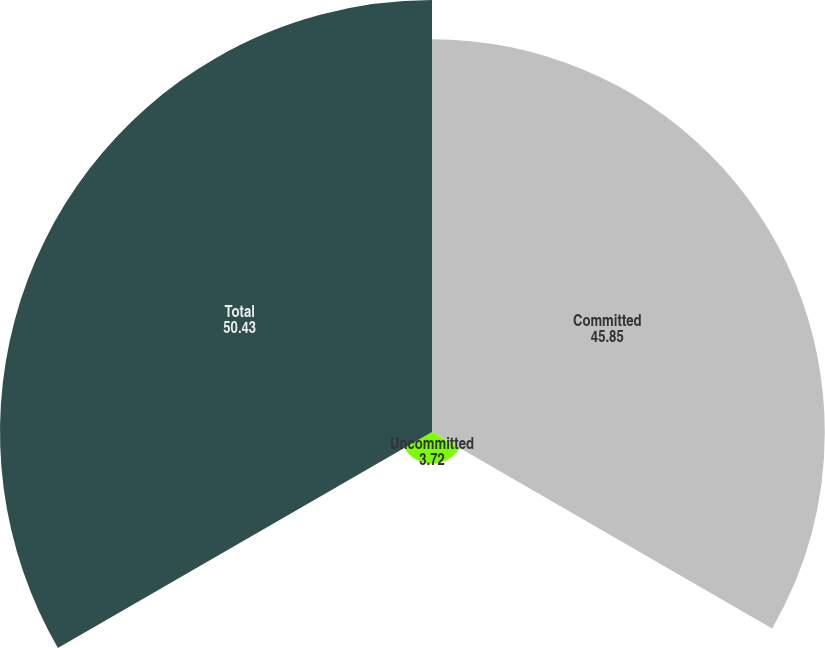Convert chart. <chart><loc_0><loc_0><loc_500><loc_500><pie_chart><fcel>Committed<fcel>Uncommitted<fcel>Total<nl><fcel>45.85%<fcel>3.72%<fcel>50.43%<nl></chart> 